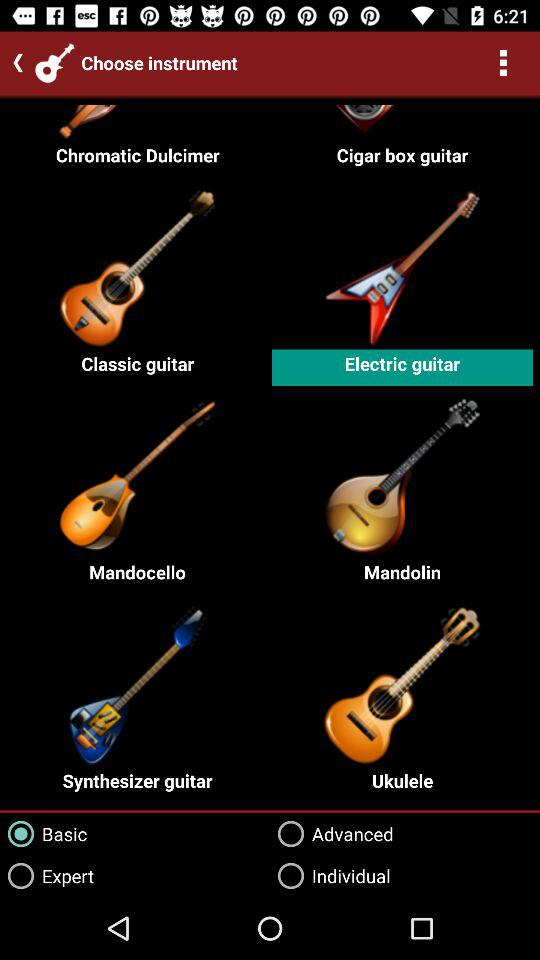What is the selected instrument? The selected instrument is "Electric guitar". 